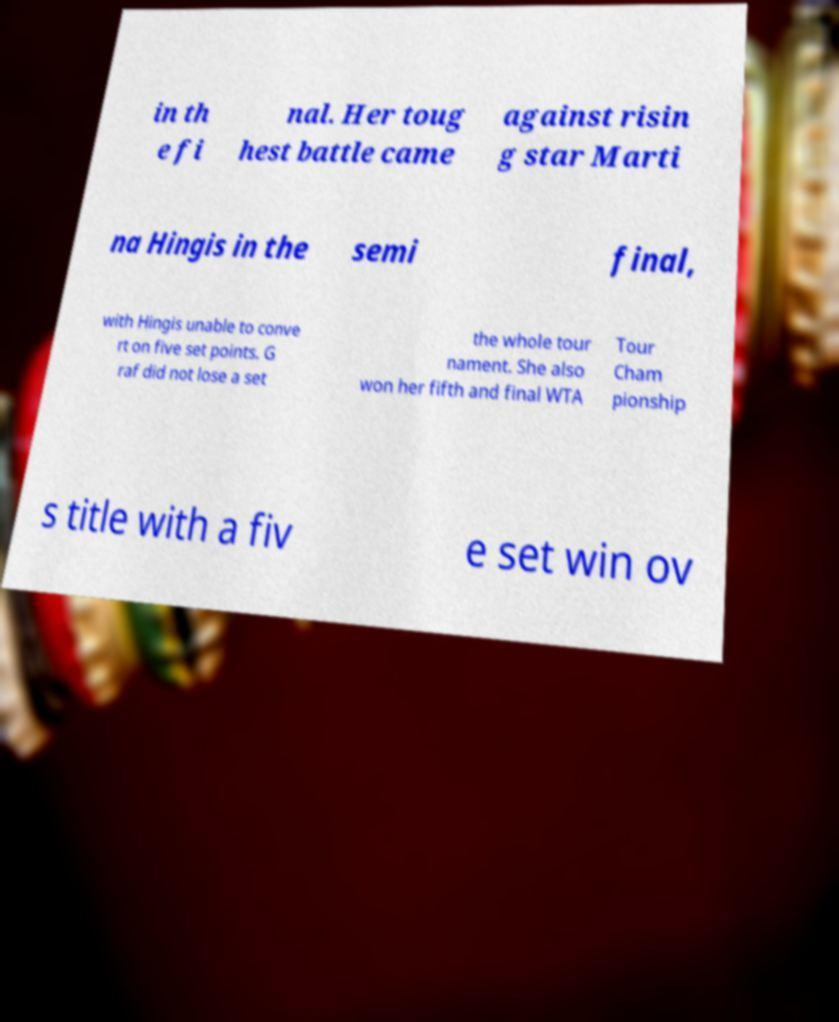Please read and relay the text visible in this image. What does it say? in th e fi nal. Her toug hest battle came against risin g star Marti na Hingis in the semi final, with Hingis unable to conve rt on five set points. G raf did not lose a set the whole tour nament. She also won her fifth and final WTA Tour Cham pionship s title with a fiv e set win ov 